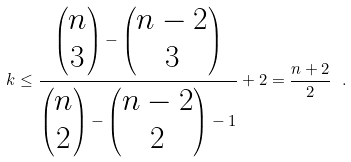<formula> <loc_0><loc_0><loc_500><loc_500>k \leq \frac { \begin{pmatrix} n \\ 3 \\ \end{pmatrix} - \begin{pmatrix} n - 2 \\ 3 \\ \end{pmatrix} } { \begin{pmatrix} n \\ 2 \\ \end{pmatrix} - \begin{pmatrix} n - 2 \\ 2 \\ \end{pmatrix} - 1 } + 2 = \frac { n + 2 } { 2 } \ .</formula> 